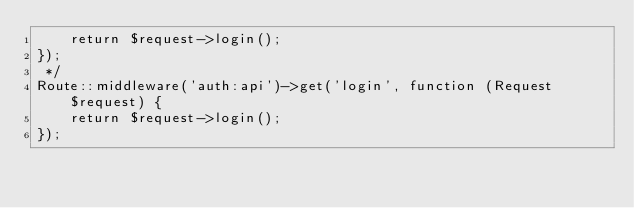Convert code to text. <code><loc_0><loc_0><loc_500><loc_500><_PHP_>    return $request->login();
});
 */
Route::middleware('auth:api')->get('login', function (Request $request) {
    return $request->login();
});
</code> 